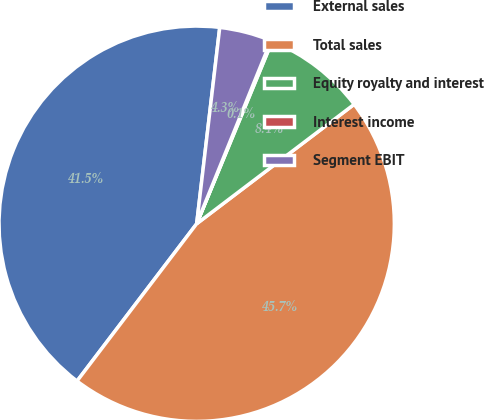<chart> <loc_0><loc_0><loc_500><loc_500><pie_chart><fcel>External sales<fcel>Total sales<fcel>Equity royalty and interest<fcel>Interest income<fcel>Segment EBIT<nl><fcel>41.51%<fcel>45.67%<fcel>8.43%<fcel>0.11%<fcel>4.27%<nl></chart> 